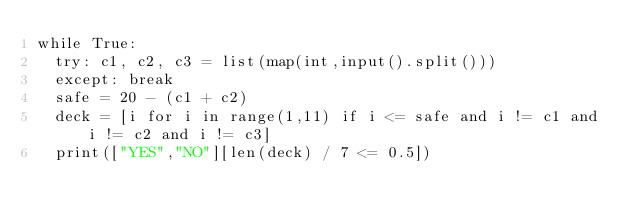Convert code to text. <code><loc_0><loc_0><loc_500><loc_500><_Python_>while True:
	try: c1, c2, c3 = list(map(int,input().split()))
	except: break
	safe = 20 - (c1 + c2)
	deck = [i for i in range(1,11) if i <= safe and i != c1 and i != c2 and i != c3]
	print(["YES","NO"][len(deck) / 7 <= 0.5])
</code> 